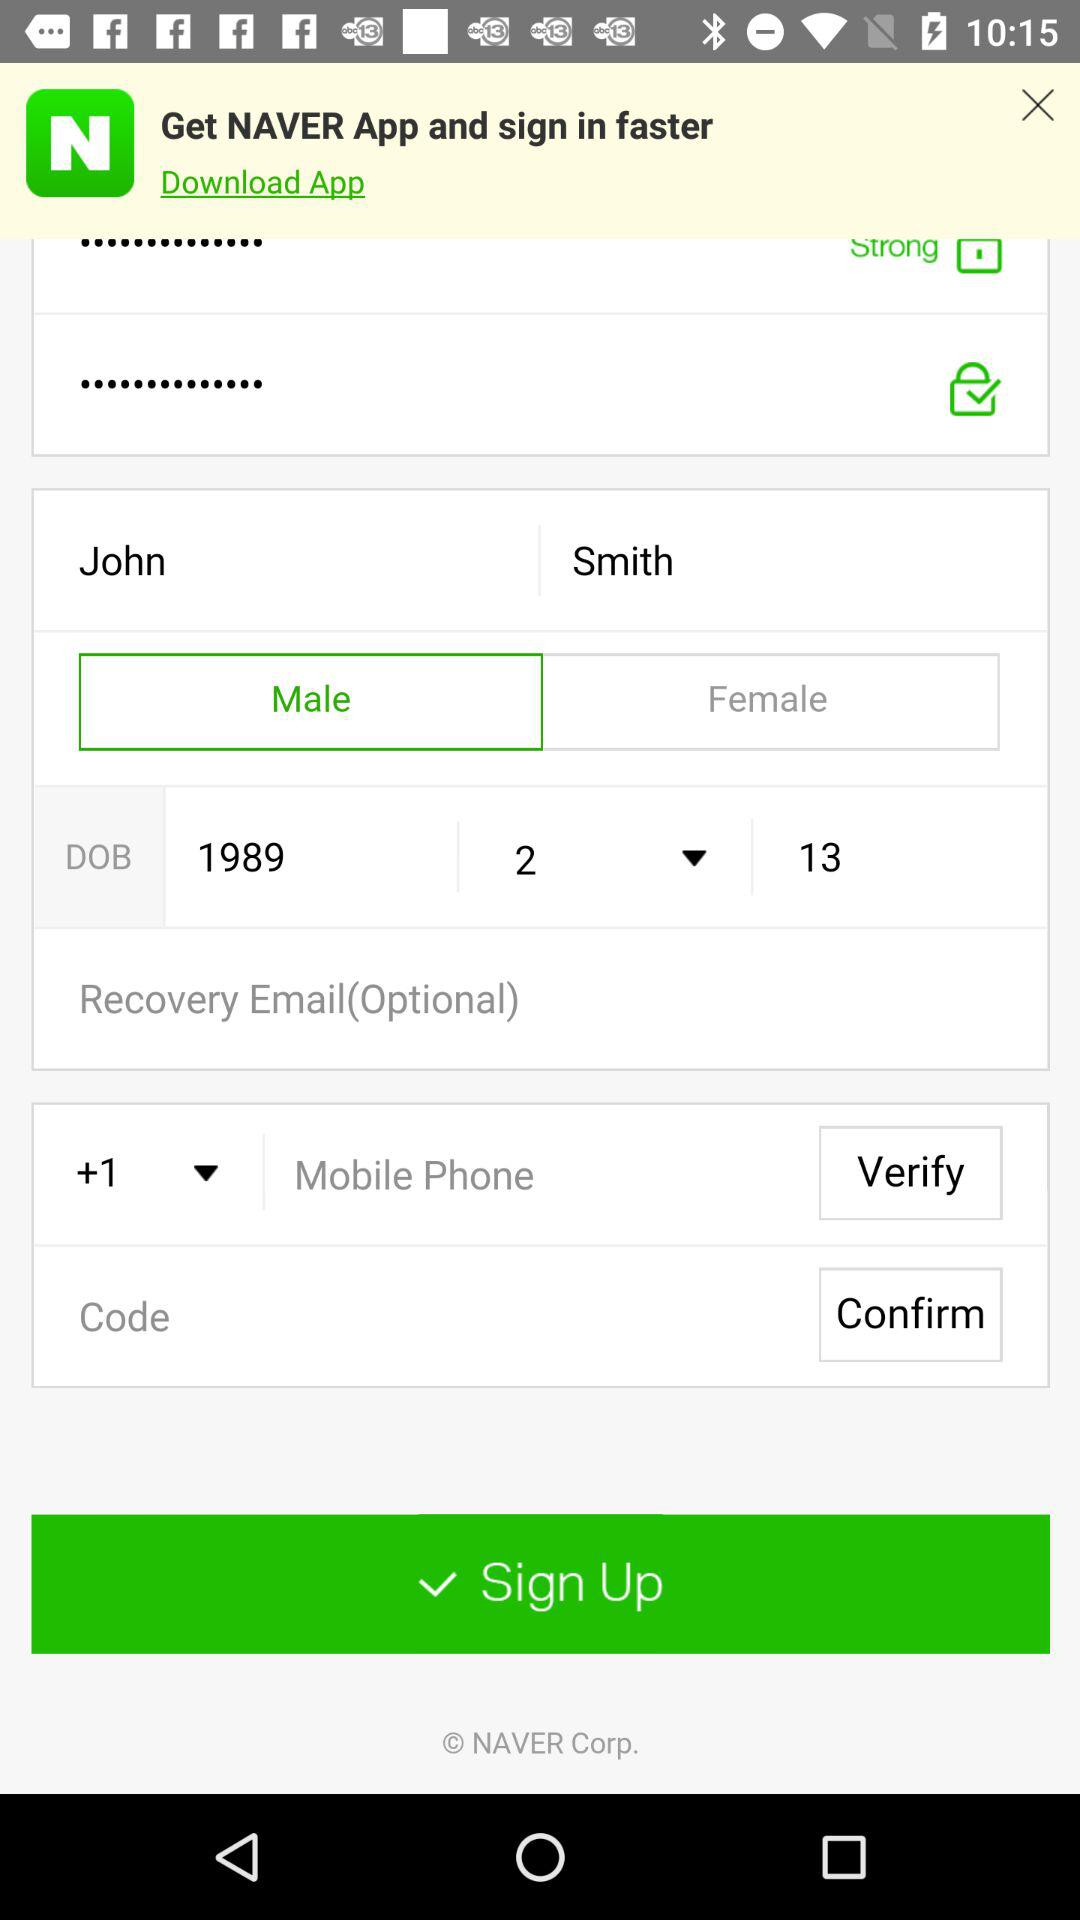What is the selected gender? The selected gender is male. 